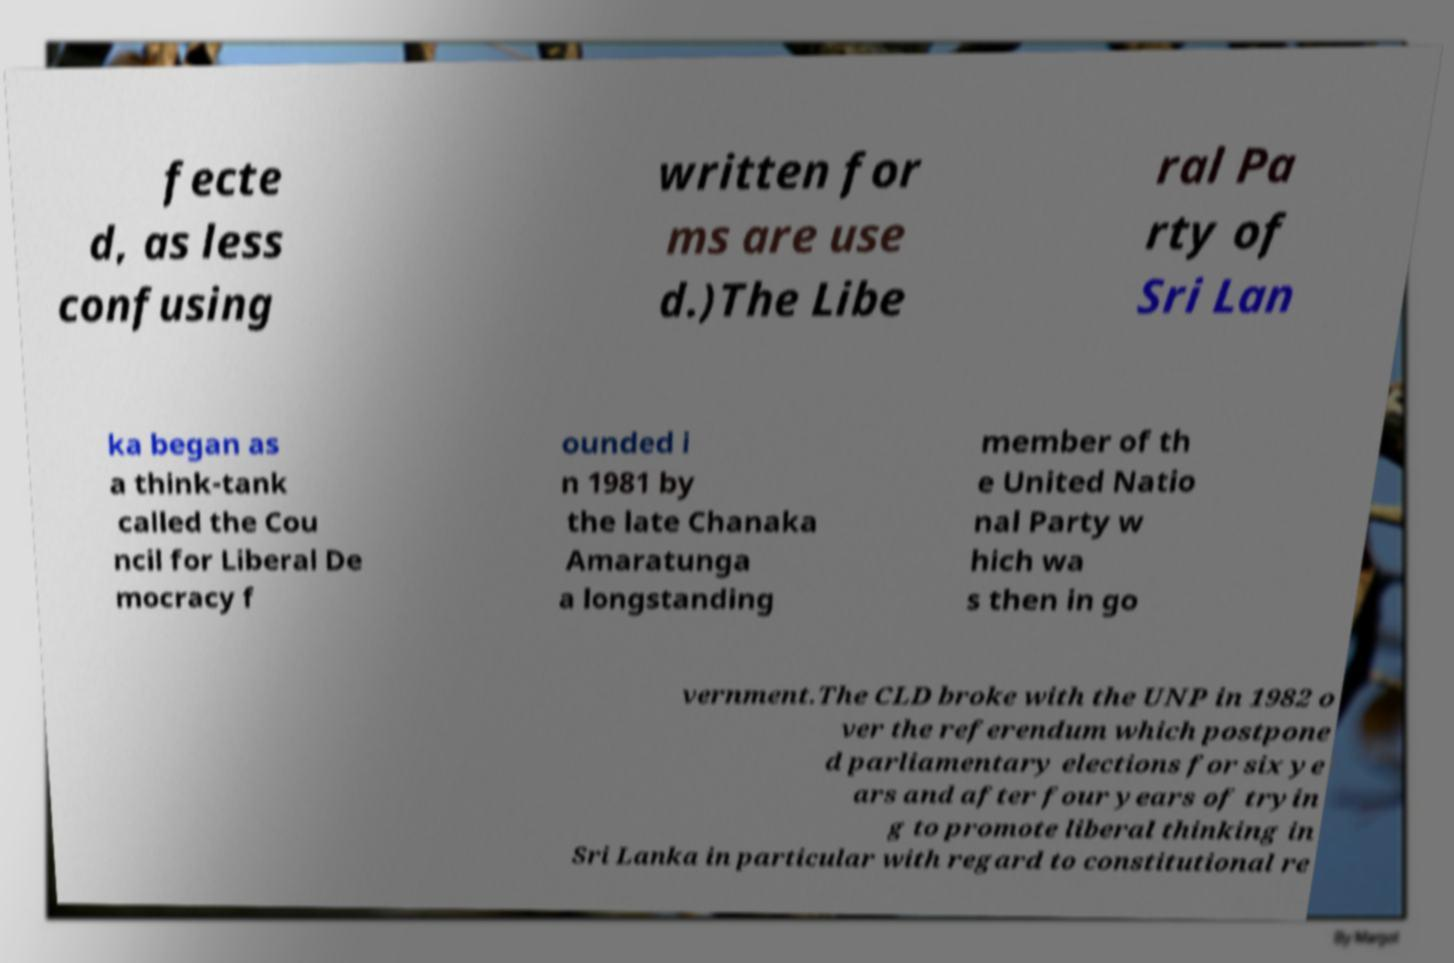I need the written content from this picture converted into text. Can you do that? fecte d, as less confusing written for ms are use d.)The Libe ral Pa rty of Sri Lan ka began as a think-tank called the Cou ncil for Liberal De mocracy f ounded i n 1981 by the late Chanaka Amaratunga a longstanding member of th e United Natio nal Party w hich wa s then in go vernment.The CLD broke with the UNP in 1982 o ver the referendum which postpone d parliamentary elections for six ye ars and after four years of tryin g to promote liberal thinking in Sri Lanka in particular with regard to constitutional re 